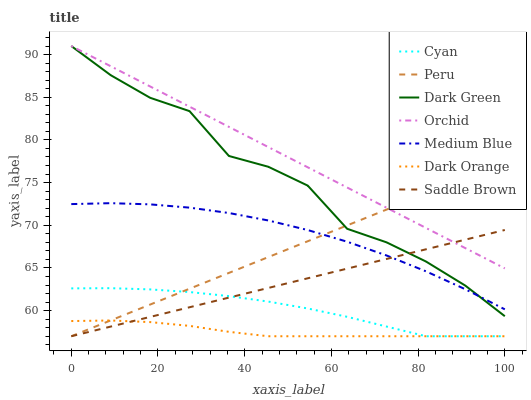Does Dark Orange have the minimum area under the curve?
Answer yes or no. Yes. Does Orchid have the maximum area under the curve?
Answer yes or no. Yes. Does Medium Blue have the minimum area under the curve?
Answer yes or no. No. Does Medium Blue have the maximum area under the curve?
Answer yes or no. No. Is Saddle Brown the smoothest?
Answer yes or no. Yes. Is Dark Green the roughest?
Answer yes or no. Yes. Is Medium Blue the smoothest?
Answer yes or no. No. Is Medium Blue the roughest?
Answer yes or no. No. Does Dark Orange have the lowest value?
Answer yes or no. Yes. Does Medium Blue have the lowest value?
Answer yes or no. No. Does Orchid have the highest value?
Answer yes or no. Yes. Does Medium Blue have the highest value?
Answer yes or no. No. Is Dark Orange less than Orchid?
Answer yes or no. Yes. Is Orchid greater than Cyan?
Answer yes or no. Yes. Does Dark Orange intersect Peru?
Answer yes or no. Yes. Is Dark Orange less than Peru?
Answer yes or no. No. Is Dark Orange greater than Peru?
Answer yes or no. No. Does Dark Orange intersect Orchid?
Answer yes or no. No. 